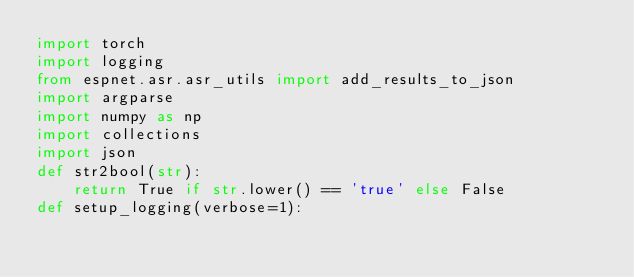Convert code to text. <code><loc_0><loc_0><loc_500><loc_500><_Python_>import torch
import logging
from espnet.asr.asr_utils import add_results_to_json
import argparse
import numpy as np
import collections
import json
def str2bool(str):
	return True if str.lower() == 'true' else False
def setup_logging(verbose=1):</code> 